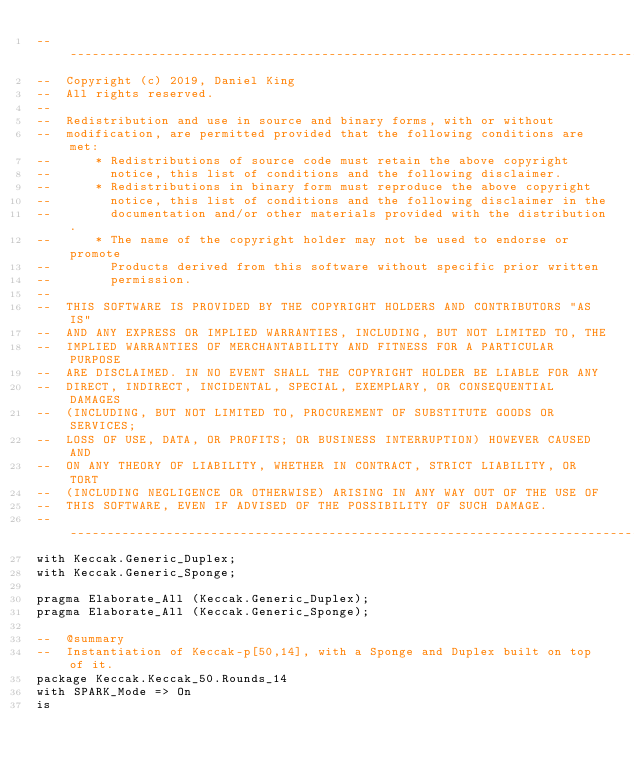Convert code to text. <code><loc_0><loc_0><loc_500><loc_500><_Ada_>-------------------------------------------------------------------------------
--  Copyright (c) 2019, Daniel King
--  All rights reserved.
--
--  Redistribution and use in source and binary forms, with or without
--  modification, are permitted provided that the following conditions are met:
--      * Redistributions of source code must retain the above copyright
--        notice, this list of conditions and the following disclaimer.
--      * Redistributions in binary form must reproduce the above copyright
--        notice, this list of conditions and the following disclaimer in the
--        documentation and/or other materials provided with the distribution.
--      * The name of the copyright holder may not be used to endorse or promote
--        Products derived from this software without specific prior written
--        permission.
--
--  THIS SOFTWARE IS PROVIDED BY THE COPYRIGHT HOLDERS AND CONTRIBUTORS "AS IS"
--  AND ANY EXPRESS OR IMPLIED WARRANTIES, INCLUDING, BUT NOT LIMITED TO, THE
--  IMPLIED WARRANTIES OF MERCHANTABILITY AND FITNESS FOR A PARTICULAR PURPOSE
--  ARE DISCLAIMED. IN NO EVENT SHALL THE COPYRIGHT HOLDER BE LIABLE FOR ANY
--  DIRECT, INDIRECT, INCIDENTAL, SPECIAL, EXEMPLARY, OR CONSEQUENTIAL DAMAGES
--  (INCLUDING, BUT NOT LIMITED TO, PROCUREMENT OF SUBSTITUTE GOODS OR SERVICES;
--  LOSS OF USE, DATA, OR PROFITS; OR BUSINESS INTERRUPTION) HOWEVER CAUSED AND
--  ON ANY THEORY OF LIABILITY, WHETHER IN CONTRACT, STRICT LIABILITY, OR TORT
--  (INCLUDING NEGLIGENCE OR OTHERWISE) ARISING IN ANY WAY OUT OF THE USE OF
--  THIS SOFTWARE, EVEN IF ADVISED OF THE POSSIBILITY OF SUCH DAMAGE.
-------------------------------------------------------------------------------
with Keccak.Generic_Duplex;
with Keccak.Generic_Sponge;

pragma Elaborate_All (Keccak.Generic_Duplex);
pragma Elaborate_All (Keccak.Generic_Sponge);

--  @summary
--  Instantiation of Keccak-p[50,14], with a Sponge and Duplex built on top of it.
package Keccak.Keccak_50.Rounds_14
with SPARK_Mode => On
is
</code> 